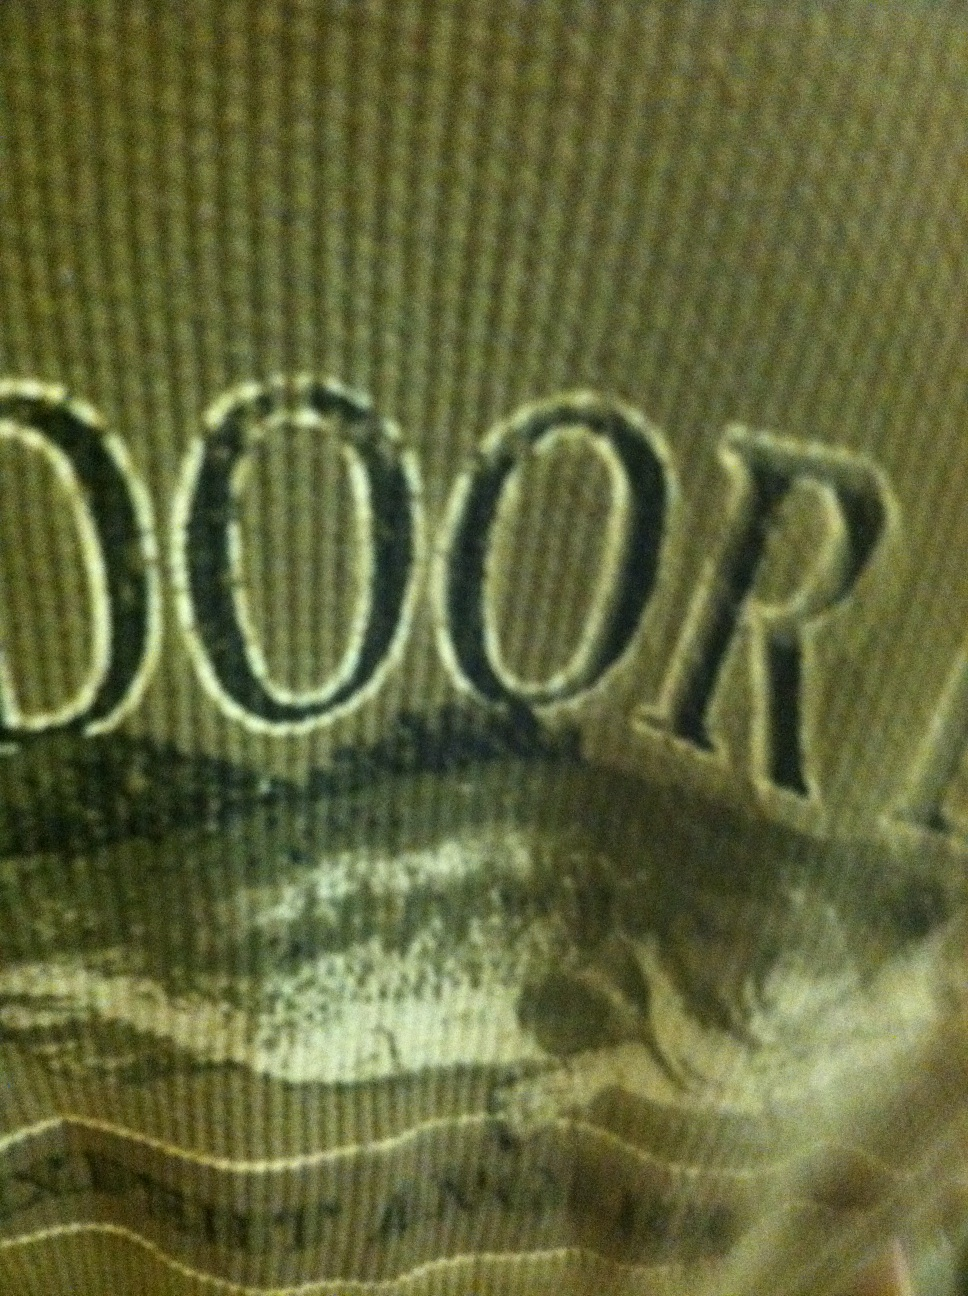Describe the design elements of the shirt. The shirt features an intriguing design with the word 'OUTDOOR' in large, bold letters. Below the text, there appears to be a scenic image, possibly of a natural landscape, enhancing the outdoor theme. 